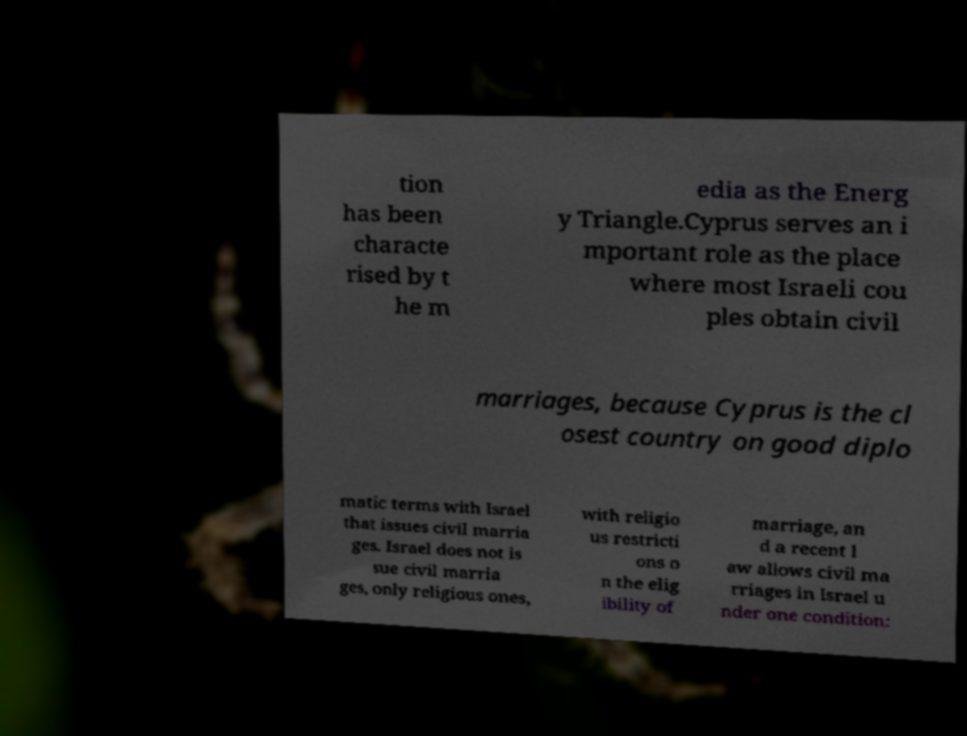For documentation purposes, I need the text within this image transcribed. Could you provide that? tion has been characte rised by t he m edia as the Energ y Triangle.Cyprus serves an i mportant role as the place where most Israeli cou ples obtain civil marriages, because Cyprus is the cl osest country on good diplo matic terms with Israel that issues civil marria ges. Israel does not is sue civil marria ges, only religious ones, with religio us restricti ons o n the elig ibility of marriage, an d a recent l aw allows civil ma rriages in Israel u nder one condition: 